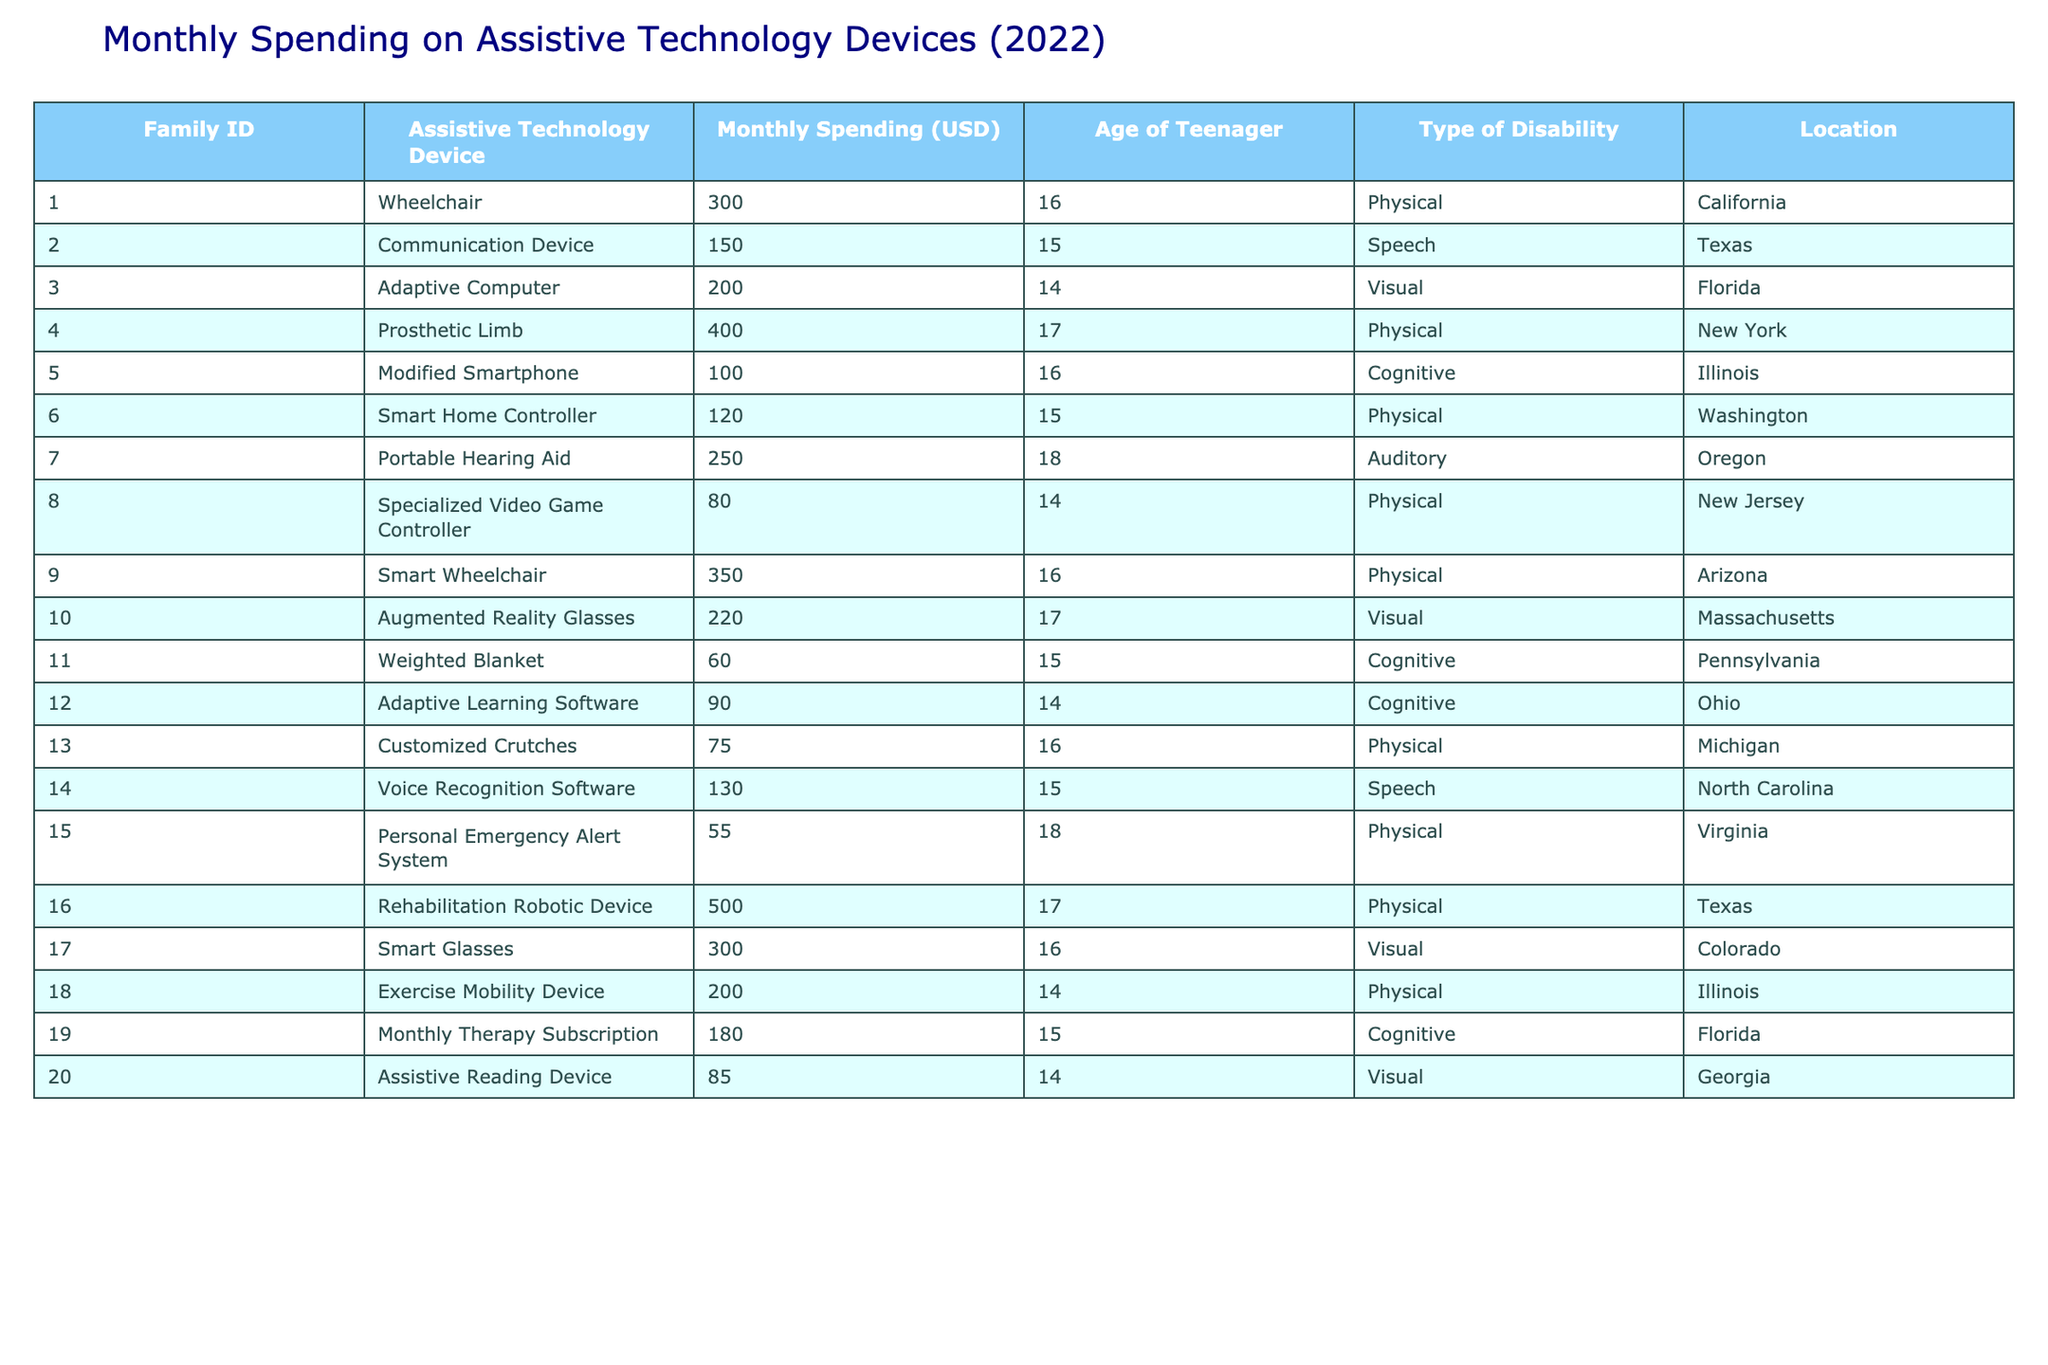What is the highest monthly spending on assistive technology devices? The highest value in the "Monthly Spending (USD)" column is 500, which corresponds to the Rehabilitation Robotic Device.
Answer: 500 How many families spent less than $100 on assistive technology devices? Only one entry in the "Monthly Spending (USD)" column is less than 100, which is for the Weighted Blanket ($60).
Answer: 1 What is the average monthly spending for families with a physical disability? The total spending for physical disabilities is 300 + 400 + 120 + 350 + 75 + 200 + 500 = 1945. There are 7 entries for physical disabilities, so the average is 1945/7 = 277.86.
Answer: 277.86 Which assistive technology device has the lowest monthly spending? The Weighted Blanket has the lowest spending of 60.
Answer: Weighted Blanket Are there more families with auditory disabilities or cognitive disabilities? There is 1 family with auditory disabilities and 5 families with cognitive disabilities, so there are more cognitive disability families.
Answer: Cognitive disabilities What is the total amount spent by families on adaptive computer devices? There is only one entry with the Adaptive Computer costing 200, so the total is 200.
Answer: 200 Does any family spend exactly $150 on assistive technology devices? Yes, Family 2 spends exactly $150 on a Communication Device.
Answer: Yes What is the combined monthly spending for all families in Florida? The entries for Florida are: $200 for Adaptive Computer, $180 for Monthly Therapy Subscription, and $85 for Assistive Reading Device. The combined total is 200 + 180 + 85 = 465.
Answer: 465 What is the median monthly spending among families? The spending amounts, when sorted, are: 55, 60, 75, 80, 85, 90, 100, 120, 130, 150, 180, 200, 220, 250, 300, 300, 350, 400, 500. There are 20 entries, so the median is the average of the 10th and 11th values: (150 + 180)/2 = 165.
Answer: 165 In which location did families spend the most on assistive technology devices? The highest individual spending is from Texas at 500 for Rehabilitation Robotic Device.
Answer: Texas 